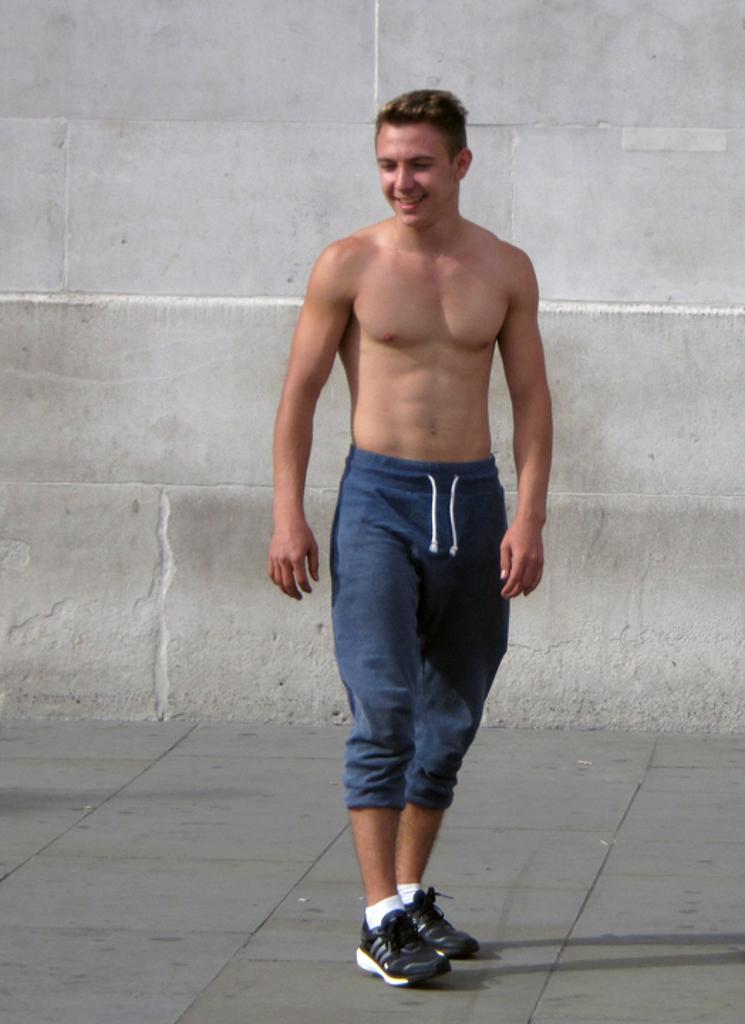Can you describe this image briefly? In the center of the image, we can see a person standing and in the background, there is a wall and at the bottom, there is a floor. 